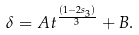Convert formula to latex. <formula><loc_0><loc_0><loc_500><loc_500>\delta = A t ^ { \frac { ( 1 - 2 s _ { 3 } ) } { 3 } } + B .</formula> 